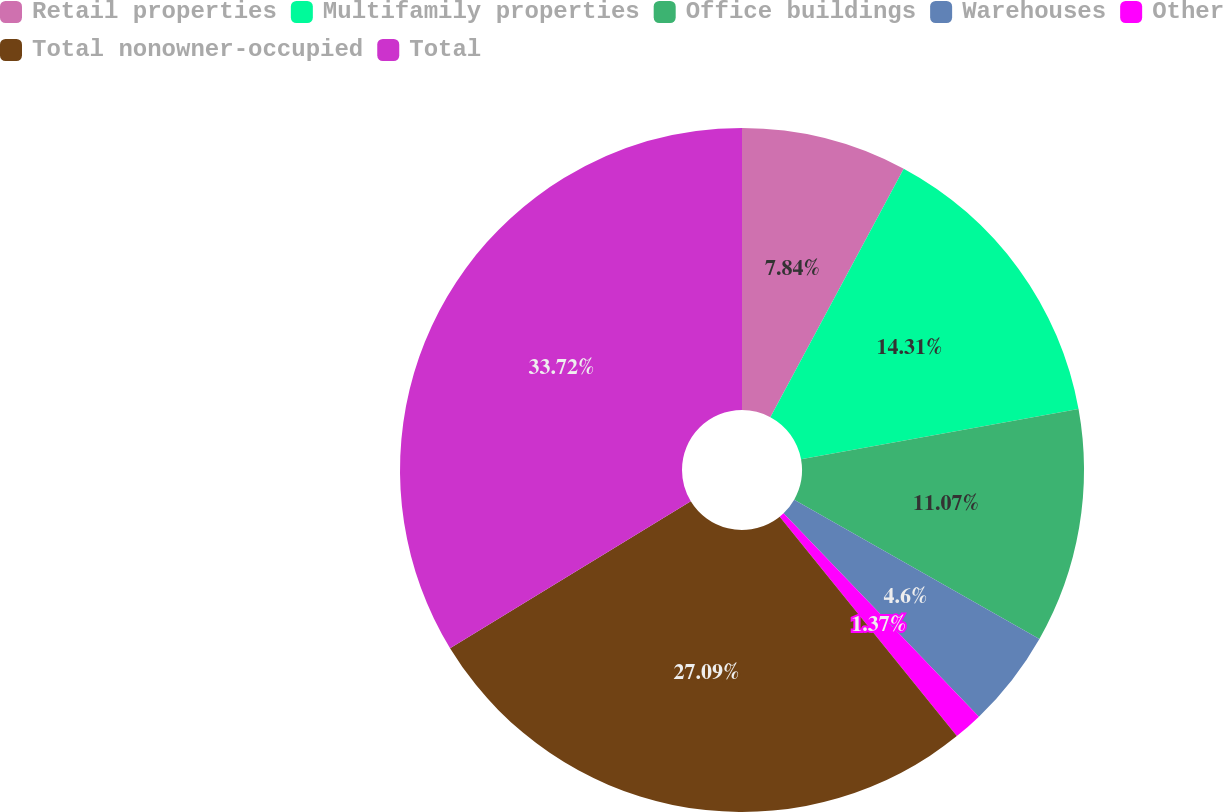Convert chart to OTSL. <chart><loc_0><loc_0><loc_500><loc_500><pie_chart><fcel>Retail properties<fcel>Multifamily properties<fcel>Office buildings<fcel>Warehouses<fcel>Other<fcel>Total nonowner-occupied<fcel>Total<nl><fcel>7.84%<fcel>14.31%<fcel>11.07%<fcel>4.6%<fcel>1.37%<fcel>27.09%<fcel>33.72%<nl></chart> 